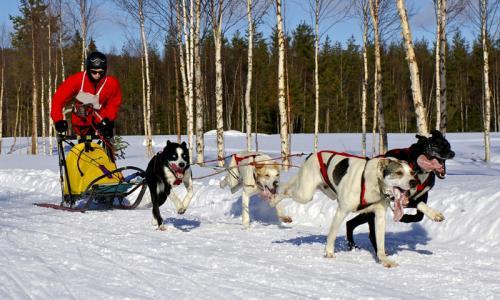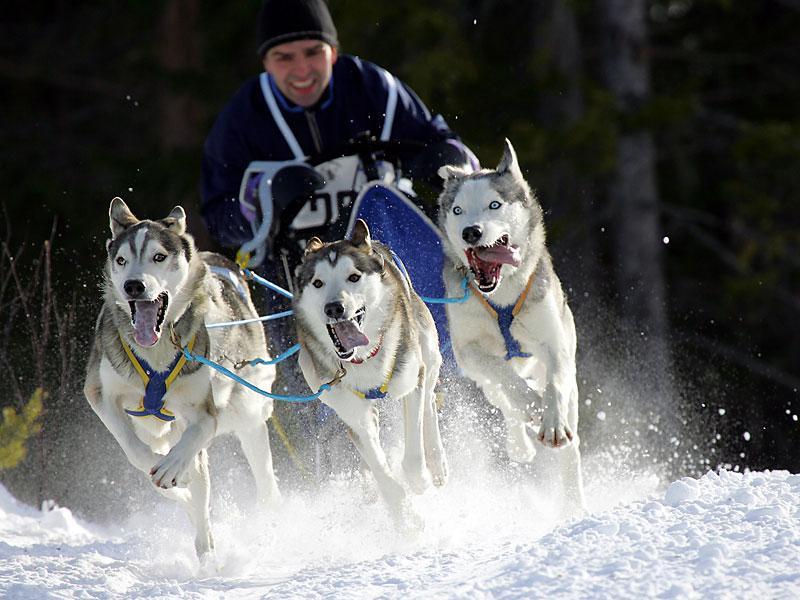The first image is the image on the left, the second image is the image on the right. Evaluate the accuracy of this statement regarding the images: "Two or fewer humans are visible.". Is it true? Answer yes or no. Yes. The first image is the image on the left, the second image is the image on the right. Evaluate the accuracy of this statement regarding the images: "At least one of the drivers is wearing yellow.". Is it true? Answer yes or no. No. 